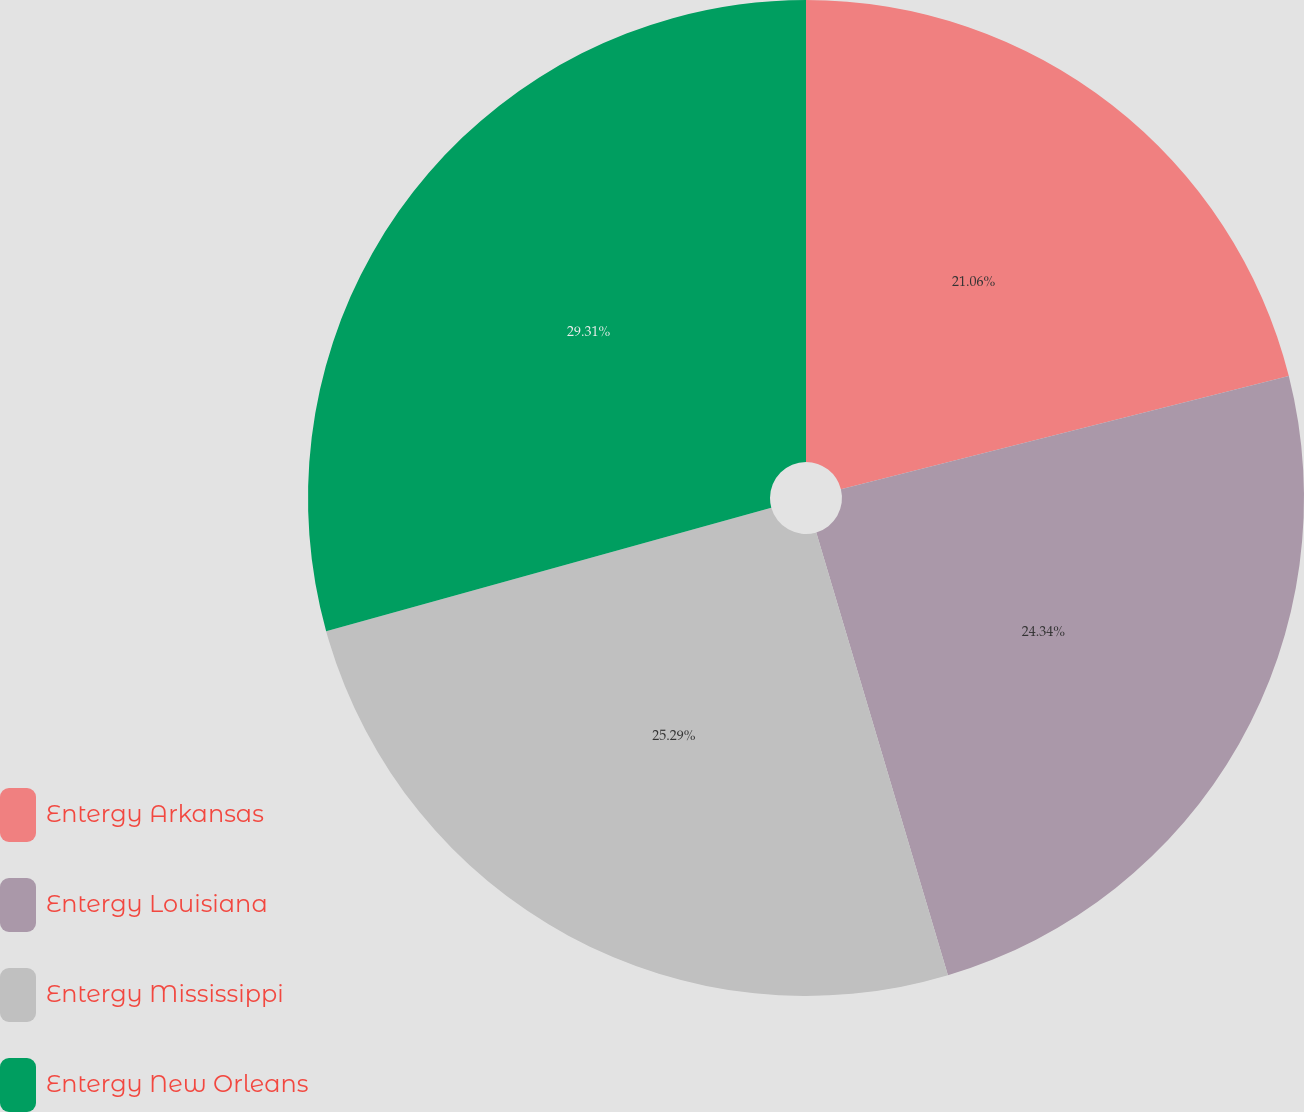Convert chart to OTSL. <chart><loc_0><loc_0><loc_500><loc_500><pie_chart><fcel>Entergy Arkansas<fcel>Entergy Louisiana<fcel>Entergy Mississippi<fcel>Entergy New Orleans<nl><fcel>21.06%<fcel>24.34%<fcel>25.29%<fcel>29.31%<nl></chart> 